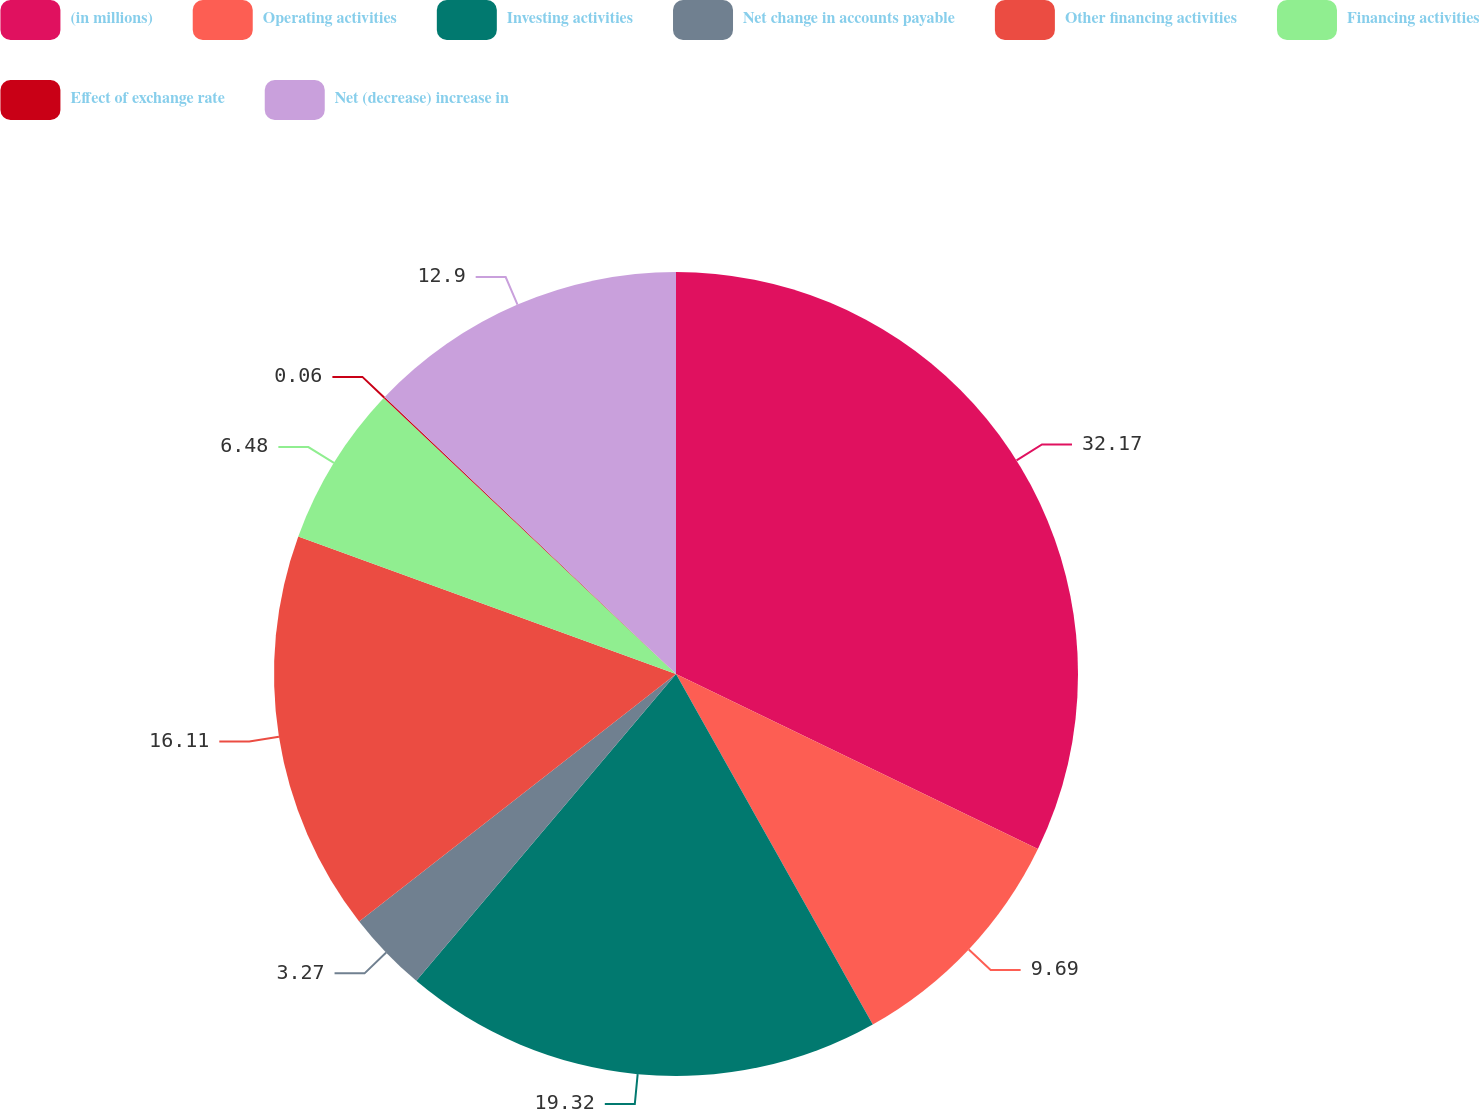<chart> <loc_0><loc_0><loc_500><loc_500><pie_chart><fcel>(in millions)<fcel>Operating activities<fcel>Investing activities<fcel>Net change in accounts payable<fcel>Other financing activities<fcel>Financing activities<fcel>Effect of exchange rate<fcel>Net (decrease) increase in<nl><fcel>32.17%<fcel>9.69%<fcel>19.32%<fcel>3.27%<fcel>16.11%<fcel>6.48%<fcel>0.06%<fcel>12.9%<nl></chart> 